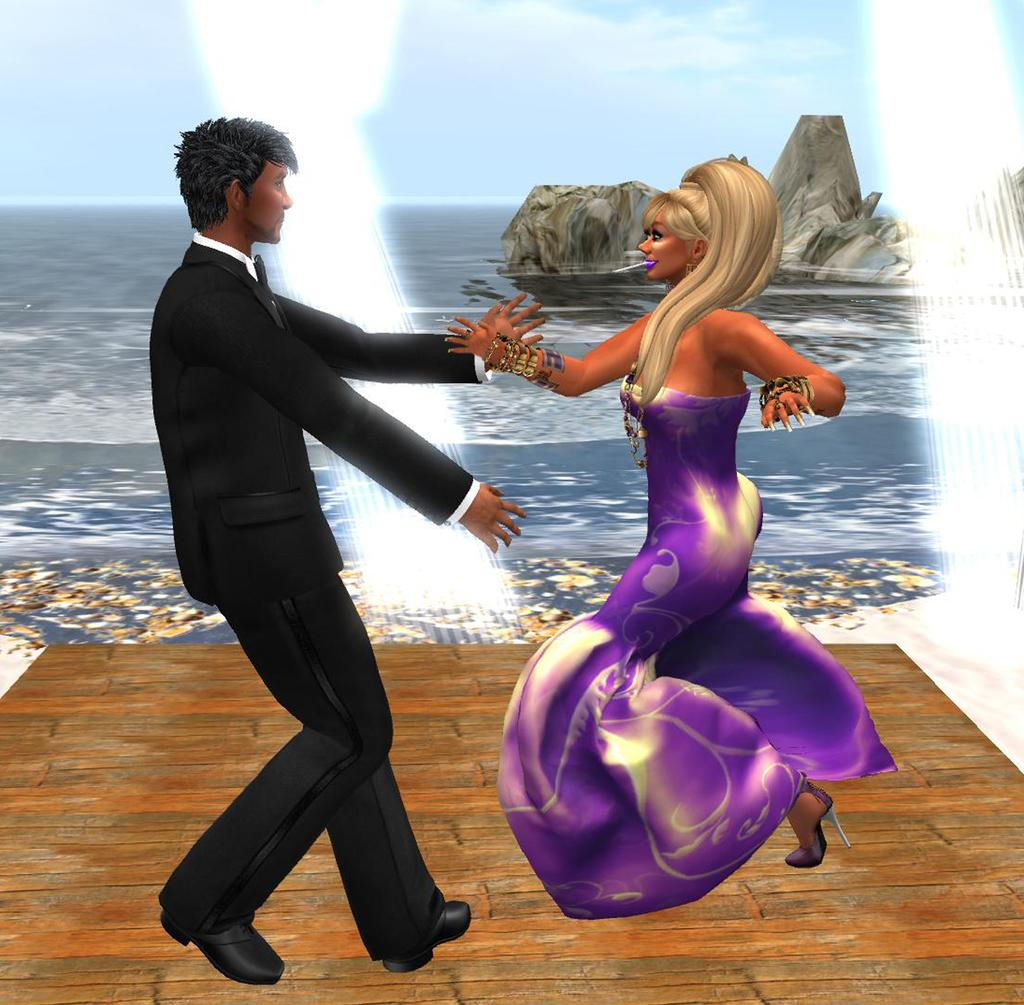How many people are present in the image? There is a man and a woman in the image. What is visible in the background of the image? Water and the sky are visible in the image. What type of tree can be seen in the image? There is no tree present in the image. What color is the grandfather's shirt in the image? There is no grandfather present in the image. 